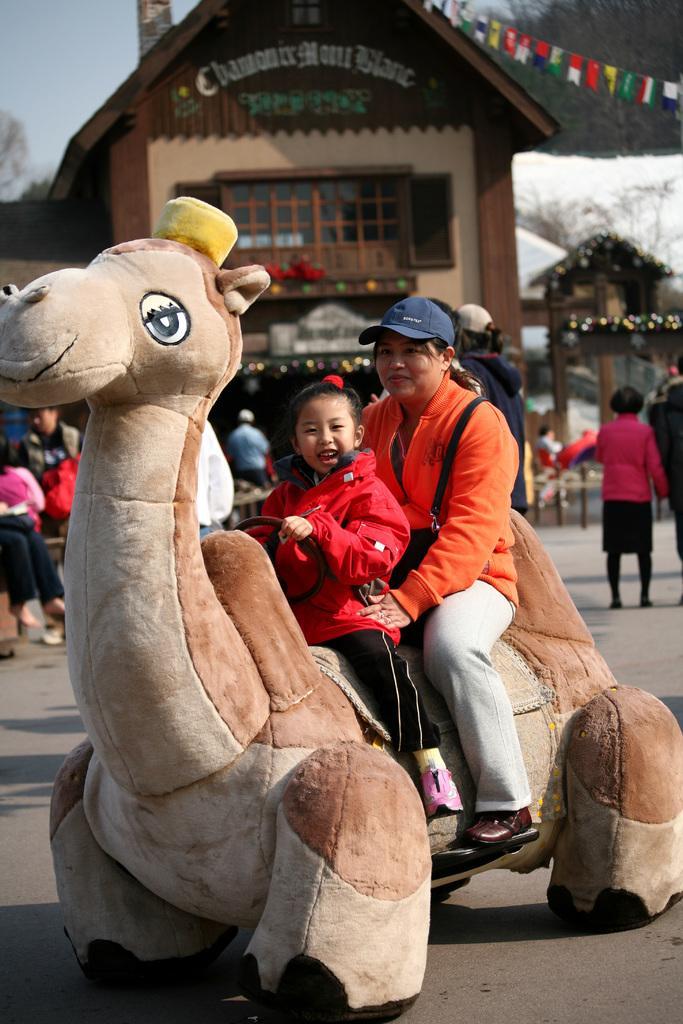In one or two sentences, can you explain what this image depicts? In the middle of the image two persons are sitting on a toy. Behind them few people are standing and walking. At the top of the image there are some buildings and trees. Behind them there is sky. 